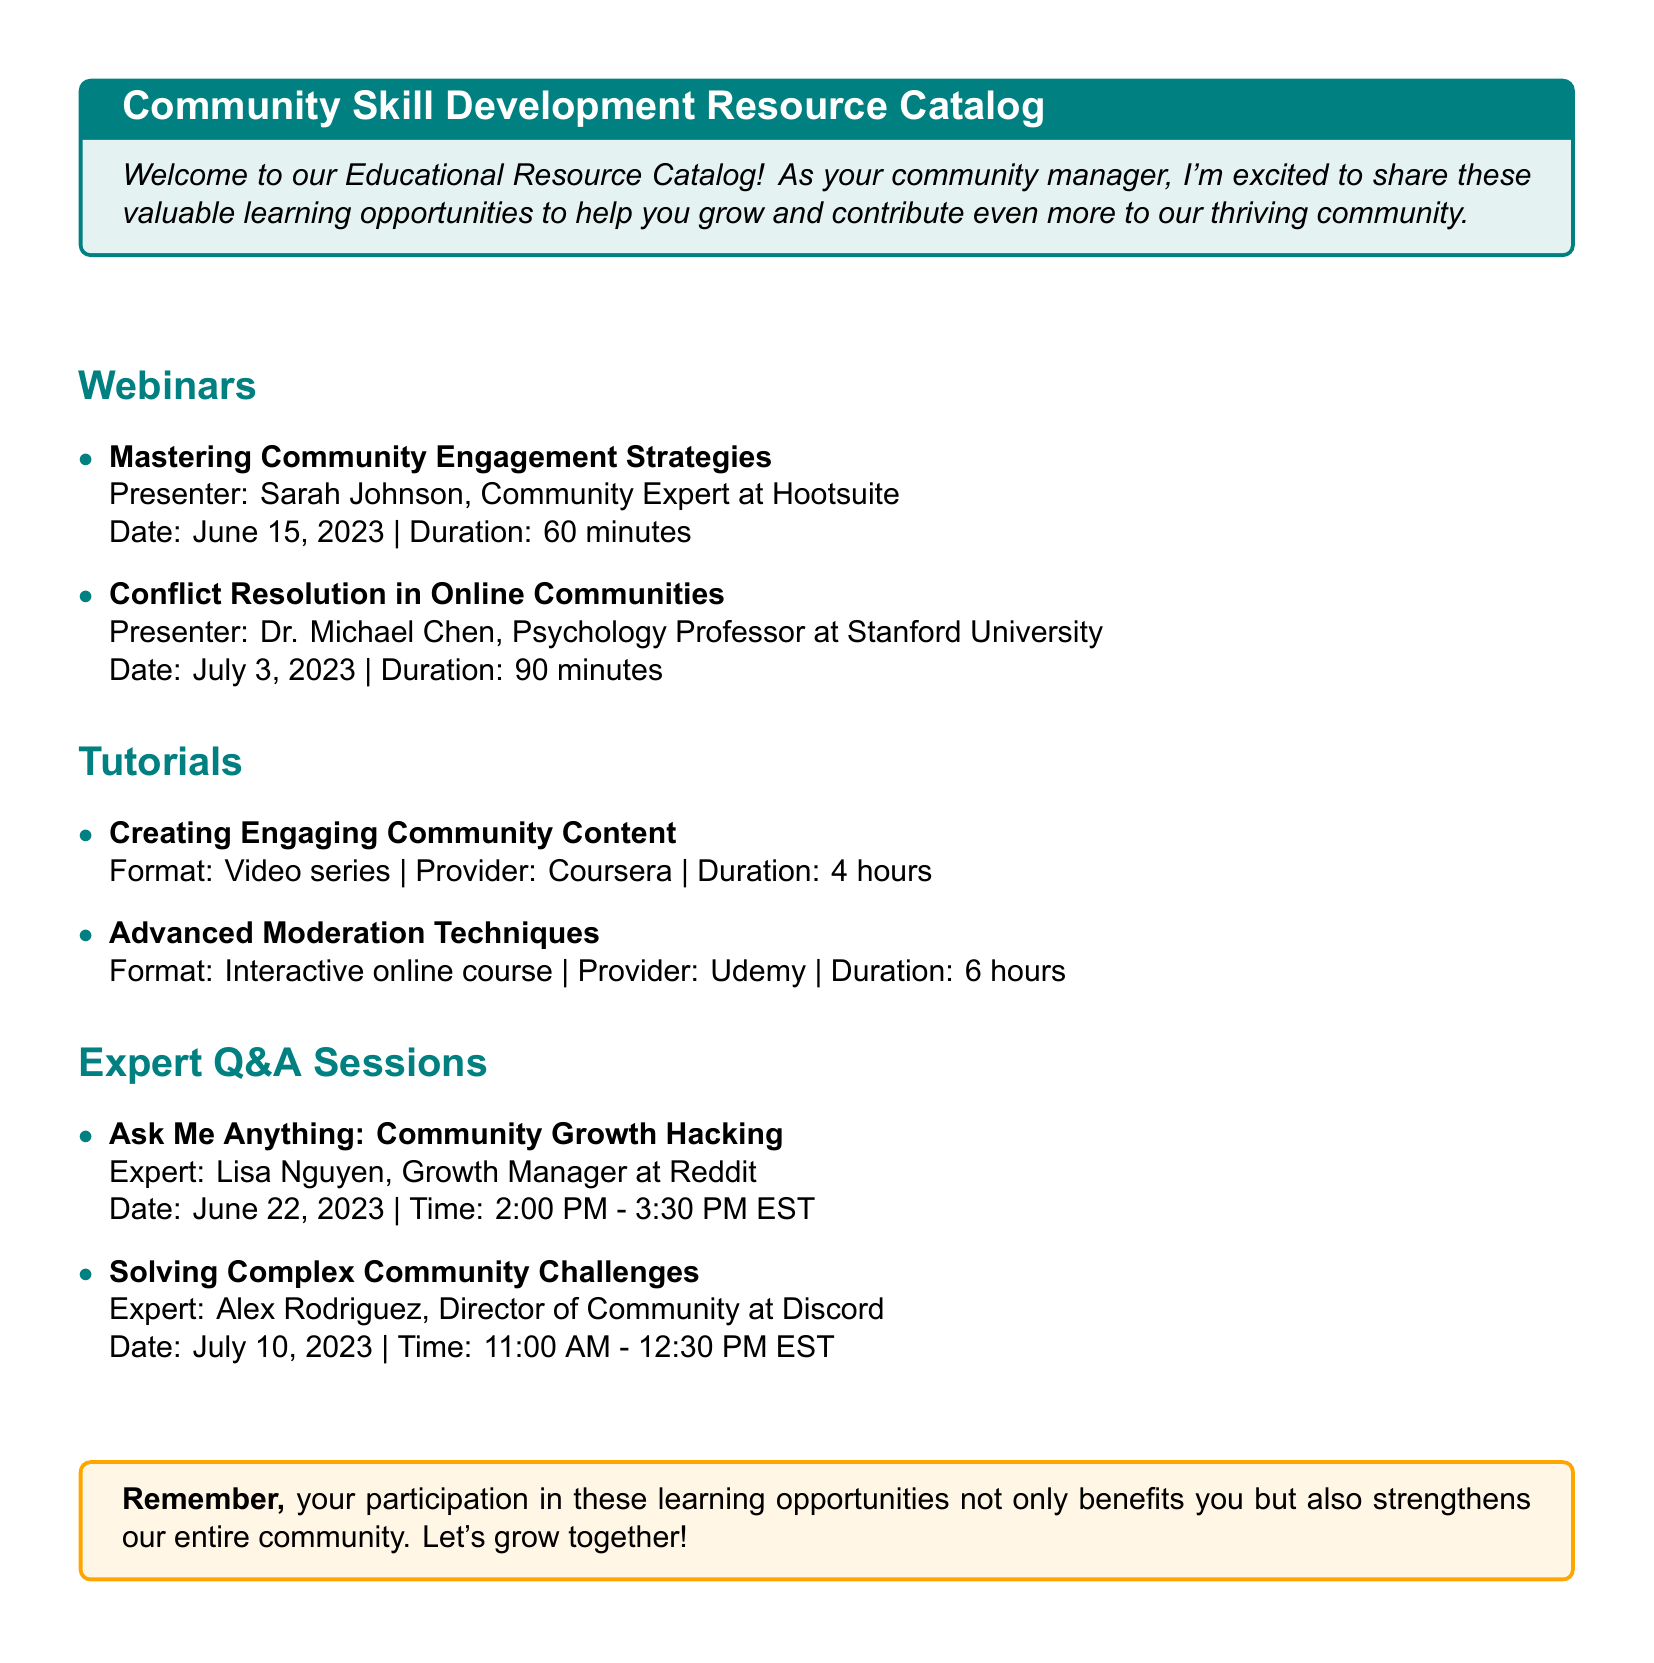What is the title of the first webinar? The first webinar is "Mastering Community Engagement Strategies."
Answer: Mastering Community Engagement Strategies Who is the presenter of the tutorial on advanced moderation techniques? The presenter of the tutorial is from Udemy.
Answer: Udemy When is the expert Q&A session on community growth hacking scheduled? The session on community growth hacking is on June 22, 2023.
Answer: June 22, 2023 How long is the duration of the "Conflict Resolution in Online Communities" webinar? The duration of the webinar is 90 minutes.
Answer: 90 minutes What format is the "Creating Engaging Community Content" tutorial offered in? The tutorial is offered in a video series format.
Answer: Video series How many webinars are listed in the document? There are two webinars listed in the document.
Answer: 2 What is the date of the "Solving Complex Community Challenges" expert Q&A session? The date of the session is July 10, 2023.
Answer: July 10, 2023 What is the duration of the "Creating Engaging Community Content" tutorial? The duration of the tutorial is 4 hours.
Answer: 4 hours 